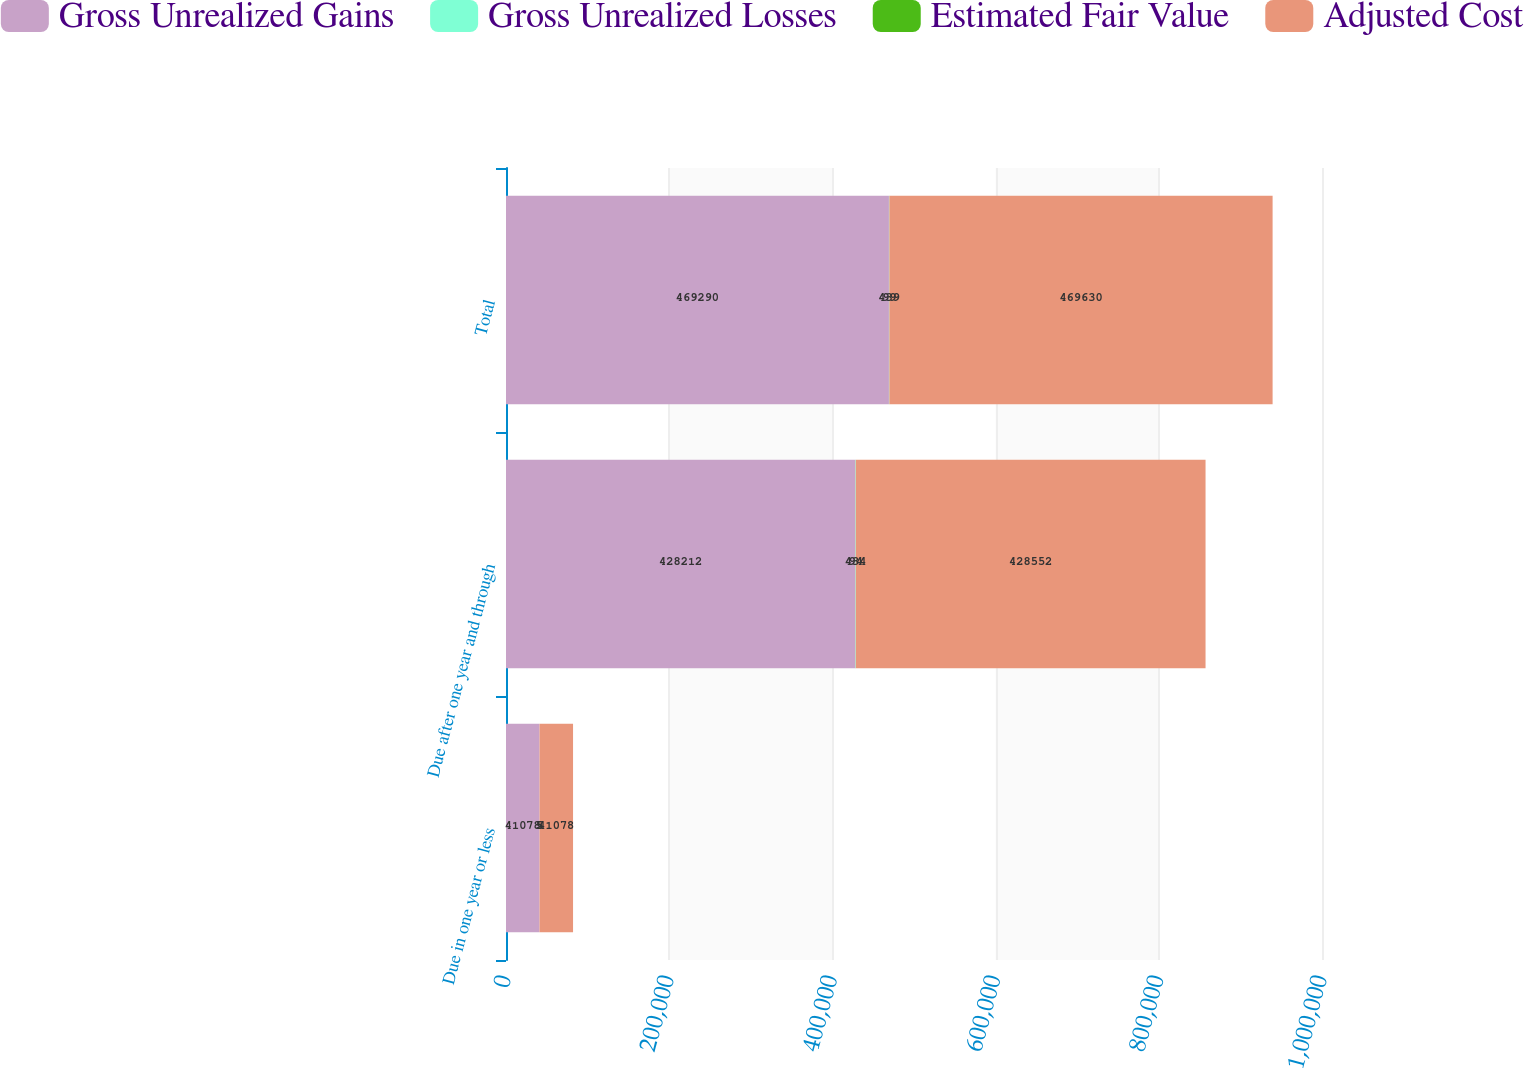Convert chart to OTSL. <chart><loc_0><loc_0><loc_500><loc_500><stacked_bar_chart><ecel><fcel>Due in one year or less<fcel>Due after one year and through<fcel>Total<nl><fcel>Gross Unrealized Gains<fcel>41078<fcel>428212<fcel>469290<nl><fcel>Gross Unrealized Losses<fcel>5<fcel>434<fcel>439<nl><fcel>Estimated Fair Value<fcel>5<fcel>94<fcel>99<nl><fcel>Adjusted Cost<fcel>41078<fcel>428552<fcel>469630<nl></chart> 